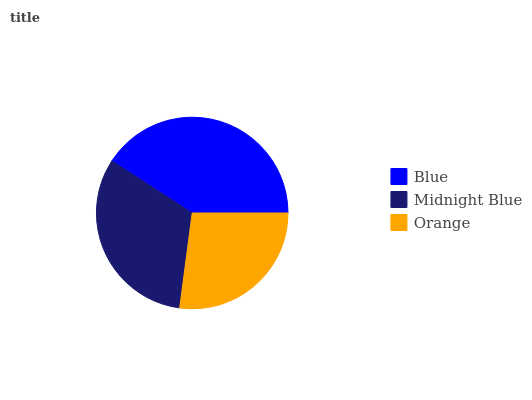Is Orange the minimum?
Answer yes or no. Yes. Is Blue the maximum?
Answer yes or no. Yes. Is Midnight Blue the minimum?
Answer yes or no. No. Is Midnight Blue the maximum?
Answer yes or no. No. Is Blue greater than Midnight Blue?
Answer yes or no. Yes. Is Midnight Blue less than Blue?
Answer yes or no. Yes. Is Midnight Blue greater than Blue?
Answer yes or no. No. Is Blue less than Midnight Blue?
Answer yes or no. No. Is Midnight Blue the high median?
Answer yes or no. Yes. Is Midnight Blue the low median?
Answer yes or no. Yes. Is Orange the high median?
Answer yes or no. No. Is Blue the low median?
Answer yes or no. No. 